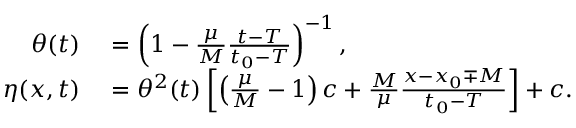Convert formula to latex. <formula><loc_0><loc_0><loc_500><loc_500>\begin{array} { r l } { \theta ( t ) } & = \left ( 1 - \frac { \mu } { M } \frac { t - T } { t _ { 0 } - T } \right ) ^ { - 1 } , } \\ { \eta ( x , t ) } & = \theta ^ { 2 } ( t ) \left [ \left ( \frac { \mu } { M } - 1 \right ) c + \frac { M } { \mu } \frac { x - x _ { 0 } \mp M } { t _ { 0 } - T } \right ] + c . } \end{array}</formula> 